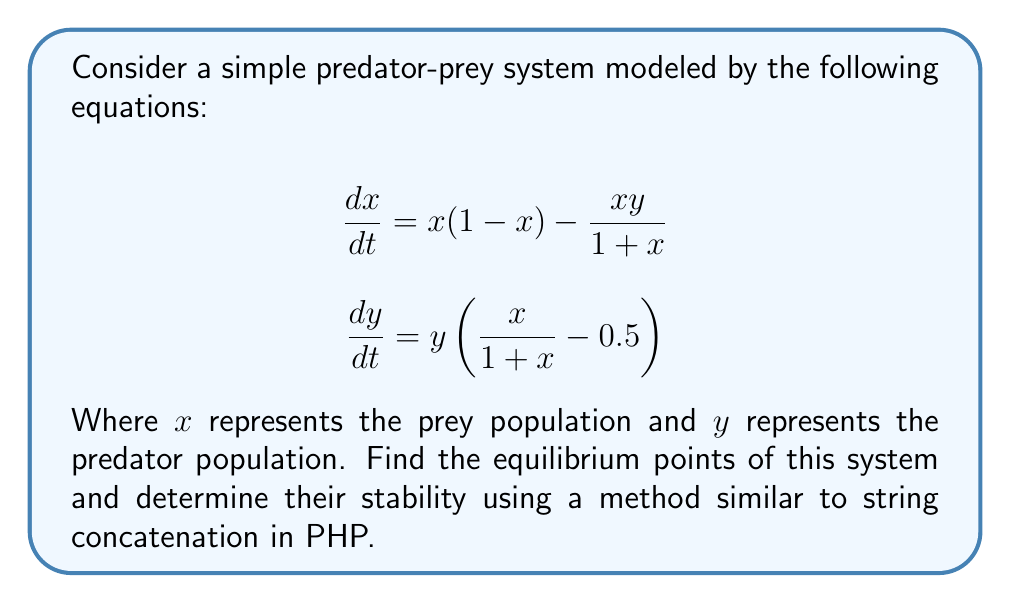Can you answer this question? 1. Find the equilibrium points:
   Set both equations to zero and solve for $x$ and $y$:
   
   $$x(1 - x) - \frac{xy}{1 + x} = 0$$
   $$y(\frac{x}{1 + x} - 0.5) = 0$$

   From the second equation, we get $y = 0$ or $\frac{x}{1 + x} = 0.5$
   
   If $y = 0$, from the first equation: $x(1 - x) = 0$, so $x = 0$ or $x = 1$
   
   If $\frac{x}{1 + x} = 0.5$, we get $x = 1$

   Equilibrium points: $(0, 0)$, $(1, 0)$, and $(1, 1)$

2. Analyze stability:
   Compute the Jacobian matrix:
   
   $$J = \begin{bmatrix}
   \frac{\partial f_1}{\partial x} & \frac{\partial f_1}{\partial y} \\
   \frac{\partial f_2}{\partial x} & \frac{\partial f_2}{\partial y}
   \end{bmatrix} = \begin{bmatrix}
   1 - 2x - \frac{y}{(1+x)^2} & -\frac{x}{1+x} \\
   \frac{y}{(1+x)^2} & \frac{x}{1+x} - 0.5
   \end{bmatrix}$$

3. Evaluate Jacobian at each equilibrium point:

   At $(0, 0)$: $J(0,0) = \begin{bmatrix} 1 & 0 \\ 0 & -0.5 \end{bmatrix}$
   Eigenvalues: $\lambda_1 = 1$, $\lambda_2 = -0.5$
   Unstable saddle point

   At $(1, 0)$: $J(1,0) = \begin{bmatrix} -1 & -0.5 \\ 0 & 0 \end{bmatrix}$
   Eigenvalues: $\lambda_1 = -1$, $\lambda_2 = 0$
   Non-hyperbolic equilibrium point

   At $(1, 1)$: $J(1,1) = \begin{bmatrix} -1.25 & -0.5 \\ 0.25 & 0 \end{bmatrix}$
   Characteristic equation: $\lambda^2 + 1.25\lambda + 0.125 = 0$
   Eigenvalues: $\lambda_1 \approx -1.1614$, $\lambda_2 \approx -0.0886$
   Stable node

4. Stability analysis is similar to PHP concatenation in that we combine different elements (partial derivatives) to form a new structure (Jacobian matrix), which we then evaluate at specific points to determine the system's behavior.
Answer: $(0,0)$: Unstable saddle point; $(1,0)$: Non-hyperbolic; $(1,1)$: Stable node 